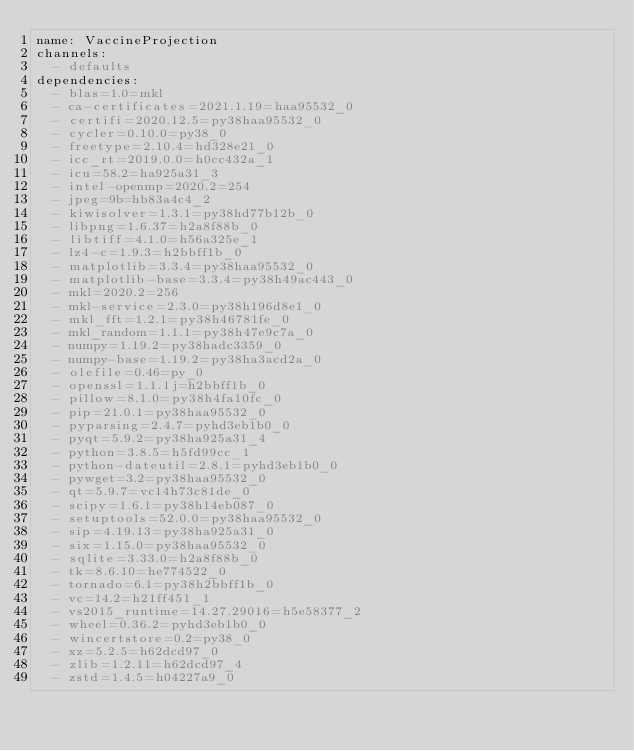Convert code to text. <code><loc_0><loc_0><loc_500><loc_500><_YAML_>name: VaccineProjection
channels:
  - defaults
dependencies:
  - blas=1.0=mkl
  - ca-certificates=2021.1.19=haa95532_0
  - certifi=2020.12.5=py38haa95532_0
  - cycler=0.10.0=py38_0
  - freetype=2.10.4=hd328e21_0
  - icc_rt=2019.0.0=h0cc432a_1
  - icu=58.2=ha925a31_3
  - intel-openmp=2020.2=254
  - jpeg=9b=hb83a4c4_2
  - kiwisolver=1.3.1=py38hd77b12b_0
  - libpng=1.6.37=h2a8f88b_0
  - libtiff=4.1.0=h56a325e_1
  - lz4-c=1.9.3=h2bbff1b_0
  - matplotlib=3.3.4=py38haa95532_0
  - matplotlib-base=3.3.4=py38h49ac443_0
  - mkl=2020.2=256
  - mkl-service=2.3.0=py38h196d8e1_0
  - mkl_fft=1.2.1=py38h46781fe_0
  - mkl_random=1.1.1=py38h47e9c7a_0
  - numpy=1.19.2=py38hadc3359_0
  - numpy-base=1.19.2=py38ha3acd2a_0
  - olefile=0.46=py_0
  - openssl=1.1.1j=h2bbff1b_0
  - pillow=8.1.0=py38h4fa10fc_0
  - pip=21.0.1=py38haa95532_0
  - pyparsing=2.4.7=pyhd3eb1b0_0
  - pyqt=5.9.2=py38ha925a31_4
  - python=3.8.5=h5fd99cc_1
  - python-dateutil=2.8.1=pyhd3eb1b0_0
  - pywget=3.2=py38haa95532_0
  - qt=5.9.7=vc14h73c81de_0
  - scipy=1.6.1=py38h14eb087_0
  - setuptools=52.0.0=py38haa95532_0
  - sip=4.19.13=py38ha925a31_0
  - six=1.15.0=py38haa95532_0
  - sqlite=3.33.0=h2a8f88b_0
  - tk=8.6.10=he774522_0
  - tornado=6.1=py38h2bbff1b_0
  - vc=14.2=h21ff451_1
  - vs2015_runtime=14.27.29016=h5e58377_2
  - wheel=0.36.2=pyhd3eb1b0_0
  - wincertstore=0.2=py38_0
  - xz=5.2.5=h62dcd97_0
  - zlib=1.2.11=h62dcd97_4
  - zstd=1.4.5=h04227a9_0</code> 